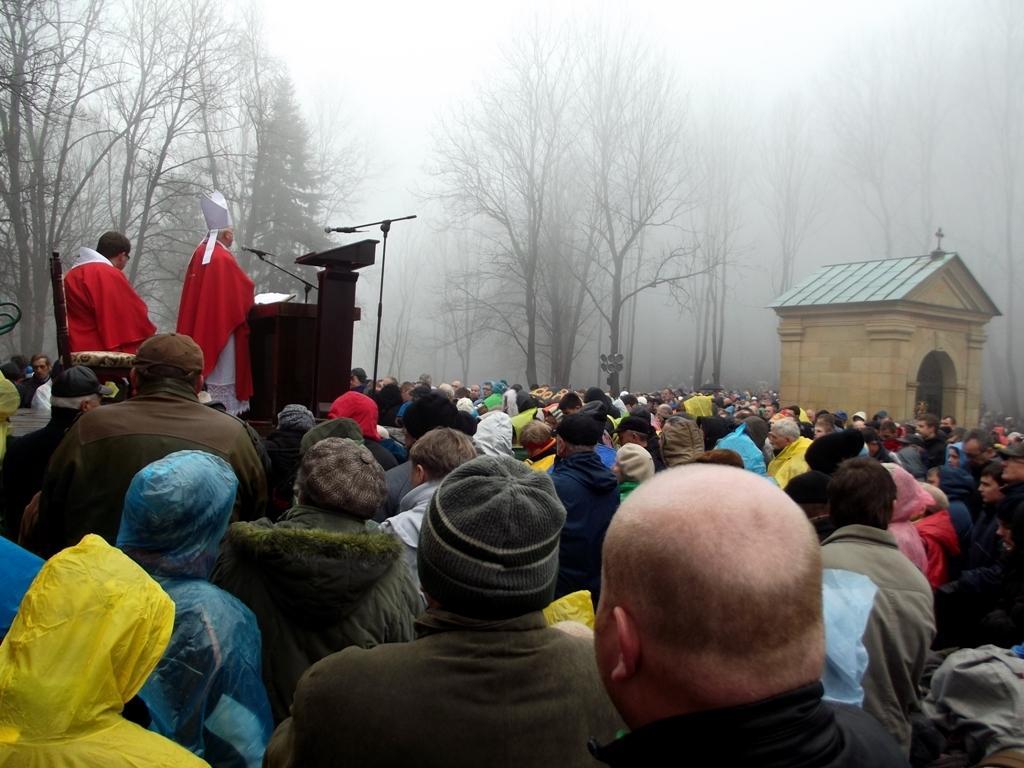Could you give a brief overview of what you see in this image? In this picture I can see few people and a man seated on the chair and I can see another man standing at a podium and speaking with the help of a microphone and I can see a book on the podium and few of them wore caps on their heads and I can see trees and another microphone on the dais and looks like a house on the right side and I can see trees and I can see fog. 